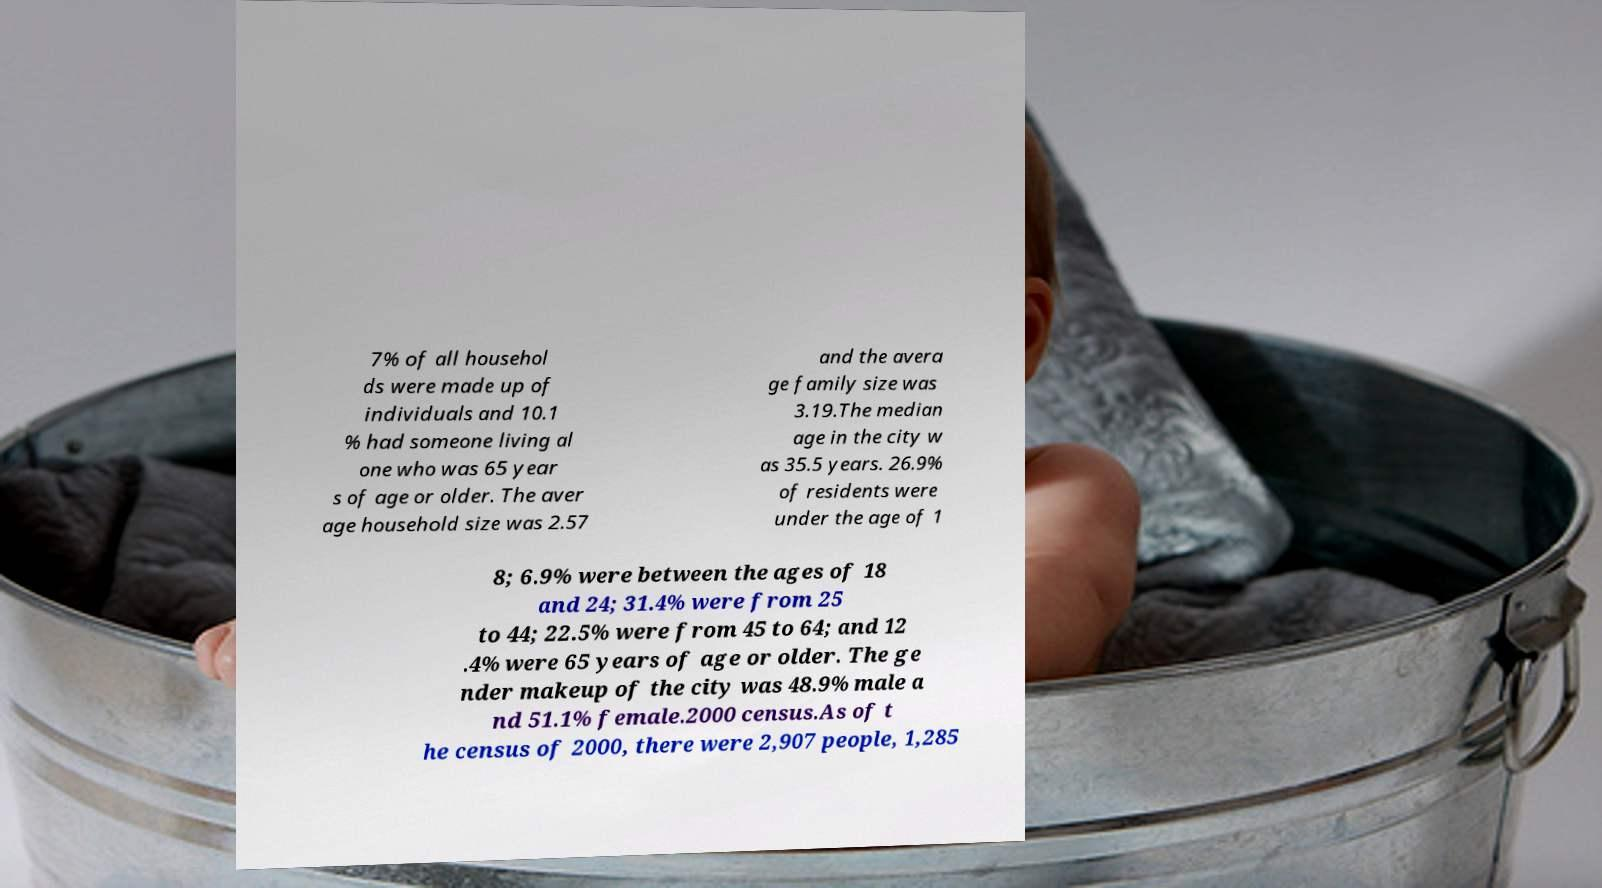For documentation purposes, I need the text within this image transcribed. Could you provide that? 7% of all househol ds were made up of individuals and 10.1 % had someone living al one who was 65 year s of age or older. The aver age household size was 2.57 and the avera ge family size was 3.19.The median age in the city w as 35.5 years. 26.9% of residents were under the age of 1 8; 6.9% were between the ages of 18 and 24; 31.4% were from 25 to 44; 22.5% were from 45 to 64; and 12 .4% were 65 years of age or older. The ge nder makeup of the city was 48.9% male a nd 51.1% female.2000 census.As of t he census of 2000, there were 2,907 people, 1,285 